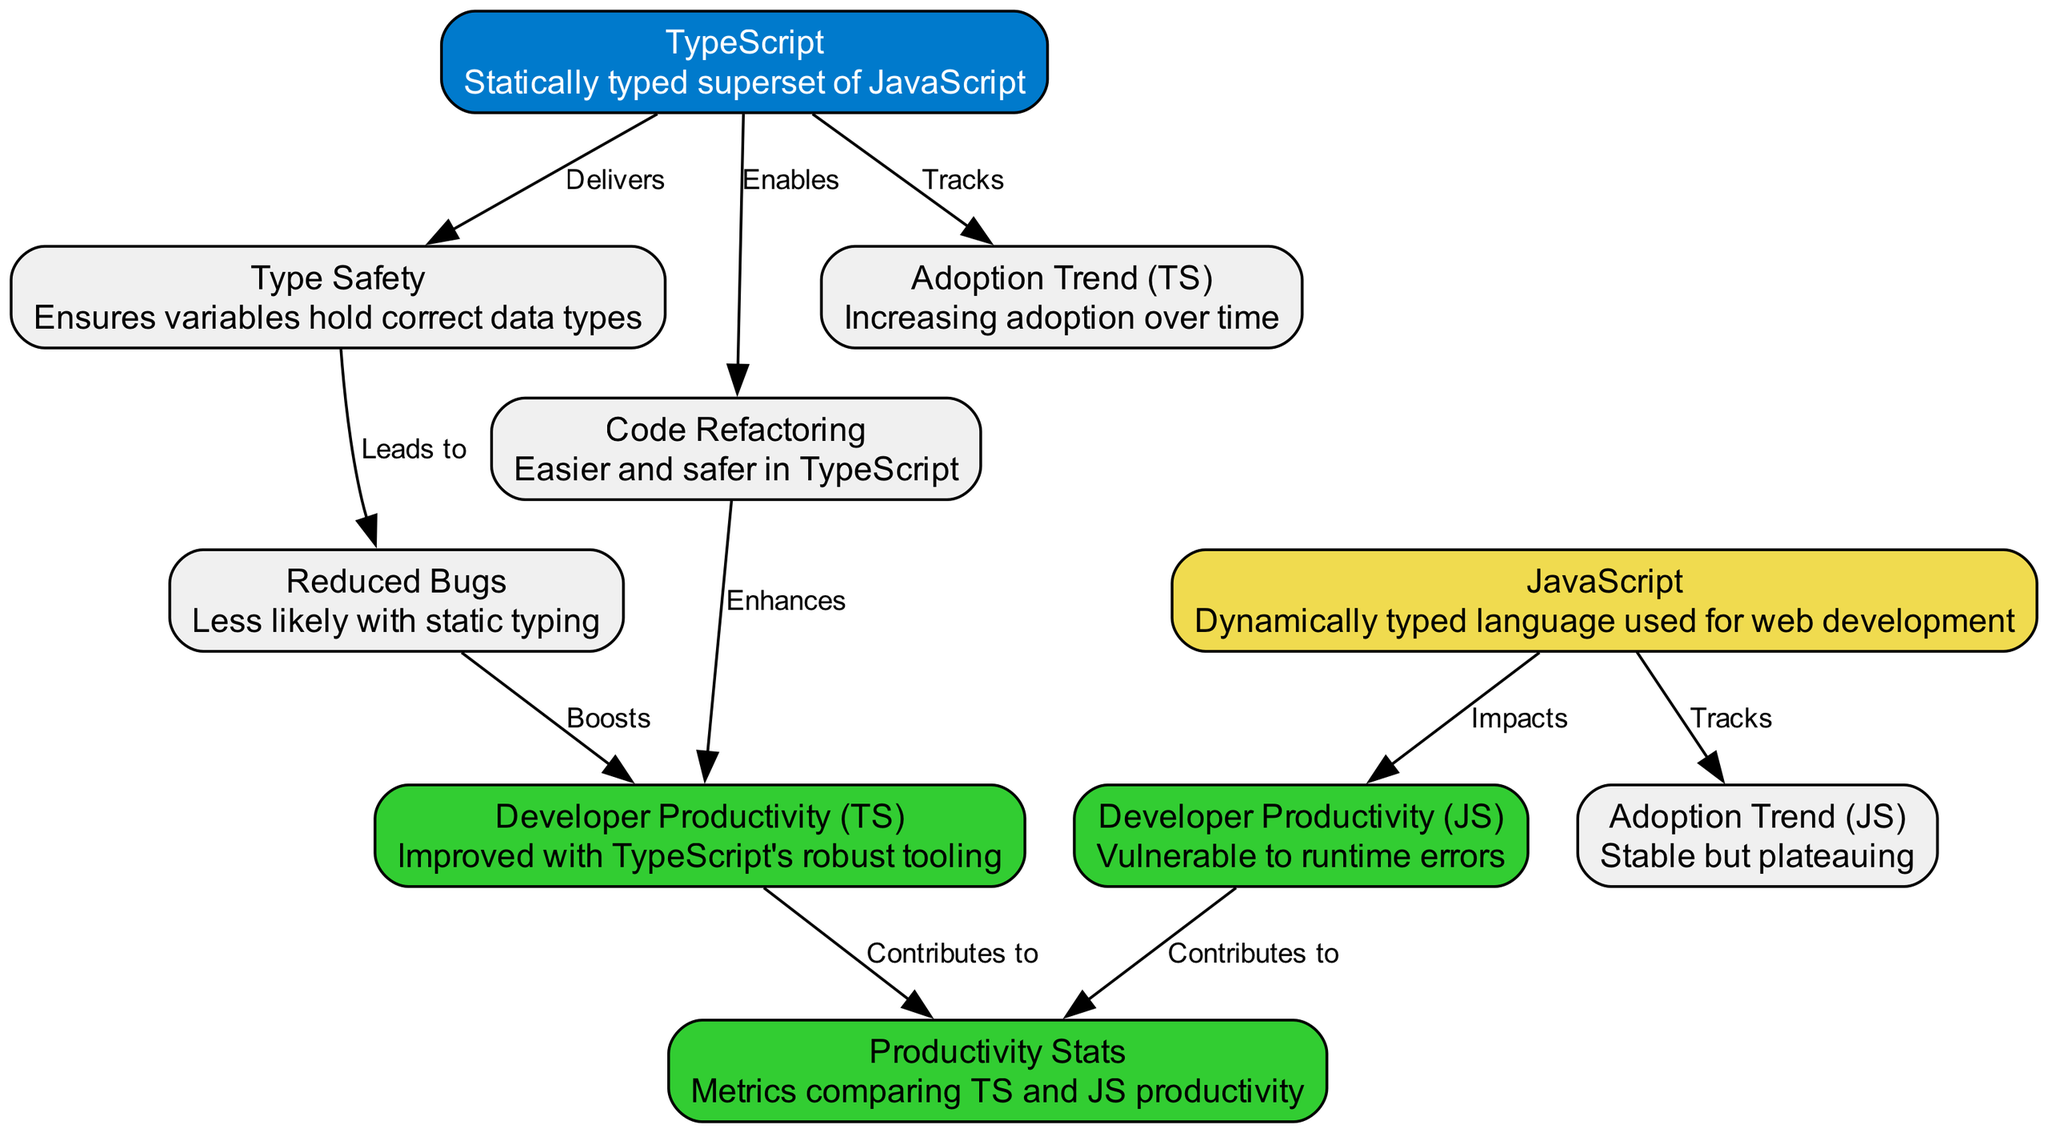What is the main distinction between TypeScript and JavaScript in this diagram? The diagram describes TypeScript as a "Statically typed superset of JavaScript," while JavaScript is labeled simply as a "Dynamically typed language used for web development." This indicates that the primary distinction lies in TypeScript's static typing feature, which is not present in JavaScript.
Answer: Statically typed superset of JavaScript How does type safety relate to reduced bugs? The diagram shows an edge from "Type Safety" to "Reduced Bugs," specifically stating that type safety "Leads to" reduced bugs. This indicates a direct relationship where having type safety contributes to fewer bugs in the code.
Answer: Leads to Which node enhances developer productivity for TypeScript? In the diagram, the edge from "Code Refactoring" to "Developer Productivity (TS)" indicates that code refactoring enhances productivity specific to TypeScript. Therefore, the "Code Refactoring" node is the one that enhances developer productivity in TypeScript.
Answer: Code Refactoring What does the adoption trend for JavaScript indicate? The diagram mentions "Adoption Trend (JS)" which is described as "Stable but plateauing." This suggests that the JavaScript adoption rate has remained constant for a while without significant increases, indicating saturation in its adoption.
Answer: Stable but plateauing Which factor contributes to productivity stats for TypeScript? The diagram illustrates that "Developer Productivity (TS)" contributes to "Productivity Stats." This means that the robust productivity associated with TypeScript developers positively influences overall productivity metrics.
Answer: Developer Productivity (TS) What impact does JavaScript have on developer productivity? The diagram states that JavaScript "Impacts" developer productivity, indicated with an edge connecting "JavaScript" and "Developer Productivity (JS)." This implies that the nature of JavaScript affects how productive developers are when using it.
Answer: Impacts How many nodes are focused on TypeScript in the diagram? By counting the nodes connected to TypeScript directly in the diagram, we can see that there are four specifically related to TypeScript: "TypeScript," "TypeSafety," "CodeRefactoring," and "AdoptionTrend_TS." Therefore, the number of nodes focused on TypeScript is four.
Answer: Four What is the relationship between reduced bugs and developer productivity in TypeScript? The diagram shows an edge from "Reduced Bugs" to "Developer Productivity (TS)" which is labeled as "Boosts." This means that by reducing bugs, the productivity of TypeScript developers is positively affected, leading to greater output and efficiency.
Answer: Boosts How does the productivity of JavaScript developers compare to that of TypeScript developers? The diagram indicates that "Developer Productivity (JS)" is linked to "Productivity Stats" and is positioned in contrast to "Developer Productivity (TS)." This suggests that JavaScript's productivity is vulnerable to runtime errors, whereas TypeScript's is not. Thus, TypeScript developers enjoy better productivity outcomes.
Answer: Vulnerable to runtime errors 